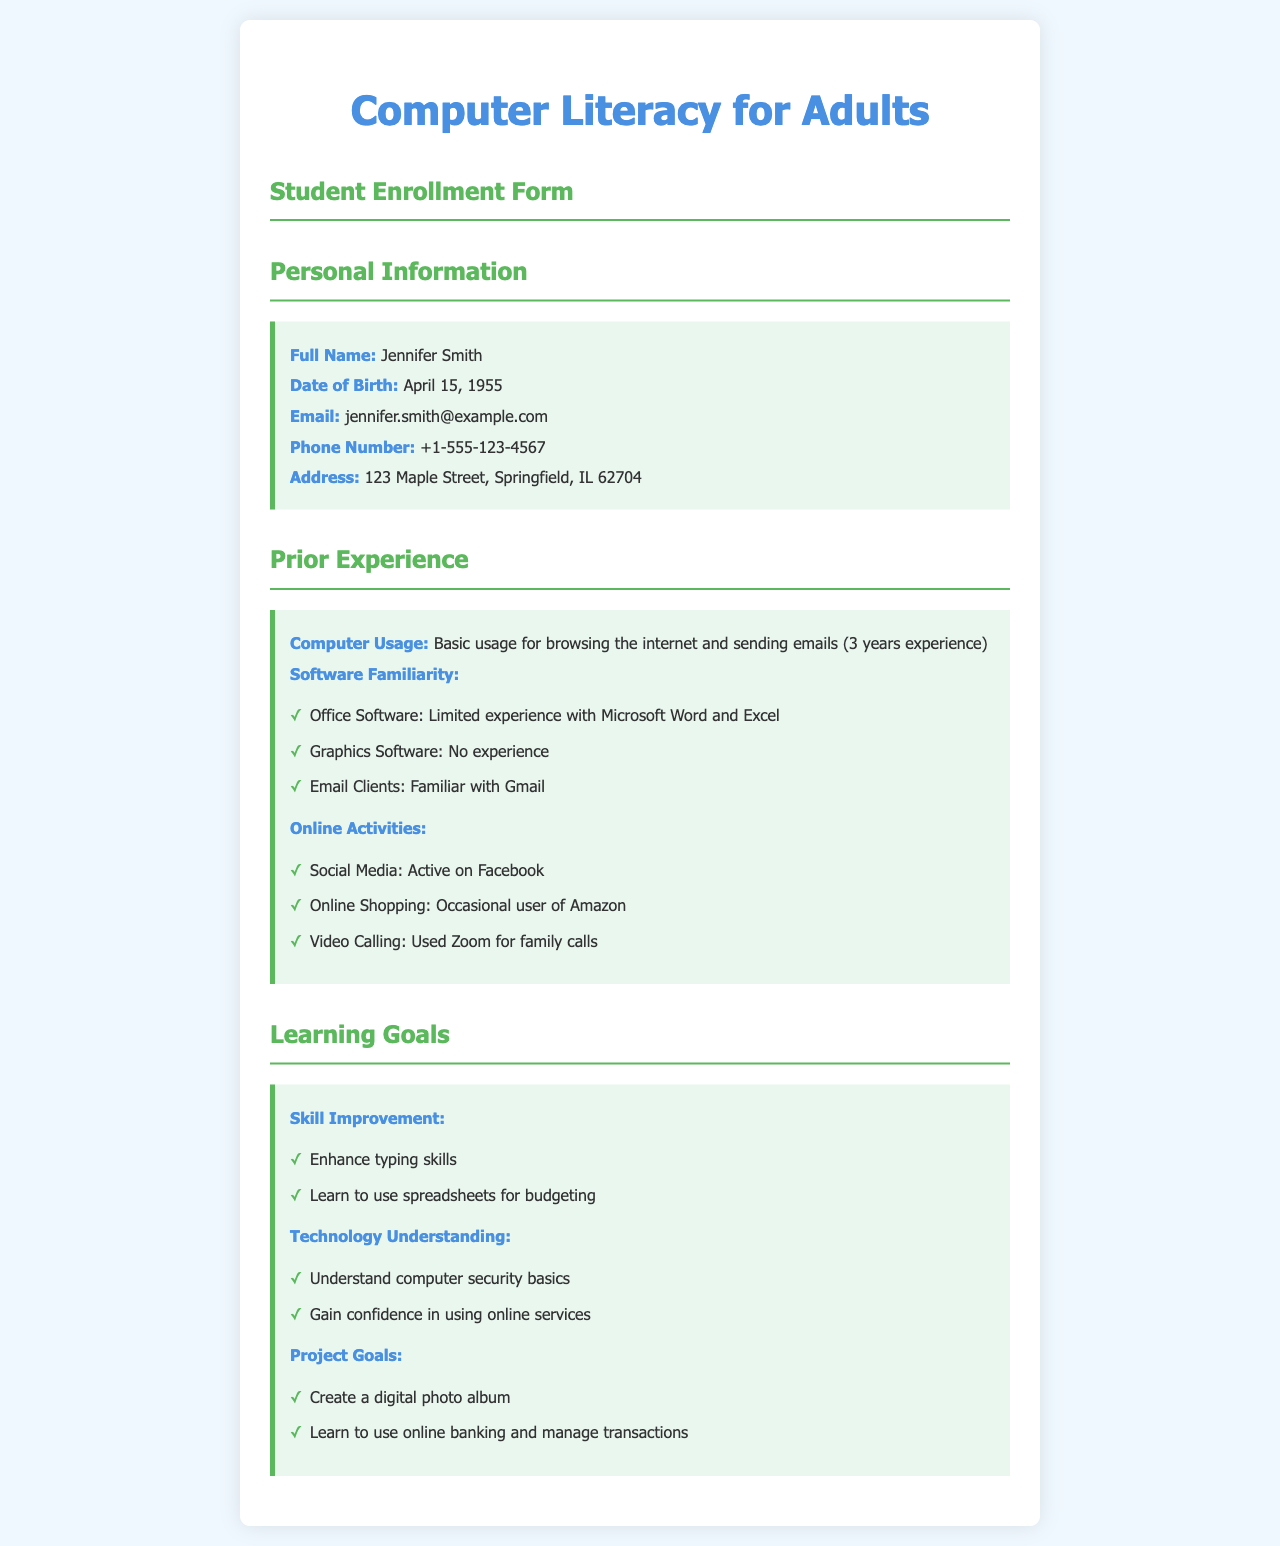What is the full name of the student? The full name is the first detail provided in the personal information section of the document.
Answer: Jennifer Smith What is the date of birth? The date of birth is listed directly under the personal information section.
Answer: April 15, 1955 How many years of computer usage experience does the student have? The experience is stated explicitly in the prior experience section, indicating a specific duration.
Answer: 3 years What software does the student have limited experience with? This information is found in the software familiarity subsection where specific software is mentioned.
Answer: Microsoft Word and Excel What social media platform is the student active on? This detail is found in the online activities subsection under social media.
Answer: Facebook What skill does the student want to enhance? The desire to enhance a specific skill is clearly stated in the learning goals section.
Answer: Typing skills What is one of the project goals listed by the student? The project goals are outlined in a bullet point format, returning a specific project mentioned.
Answer: Create a digital photo album What does the student want to understand better regarding technology? The technology understanding section contains specifics on concepts the student wishes to grasp.
Answer: Computer security basics What email client is the student familiar with? This information is part of the software familiarity in the prior experience section.
Answer: Gmail 